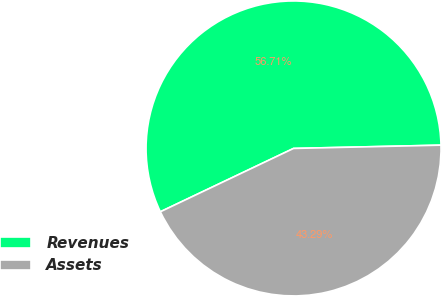Convert chart. <chart><loc_0><loc_0><loc_500><loc_500><pie_chart><fcel>Revenues<fcel>Assets<nl><fcel>56.71%<fcel>43.29%<nl></chart> 